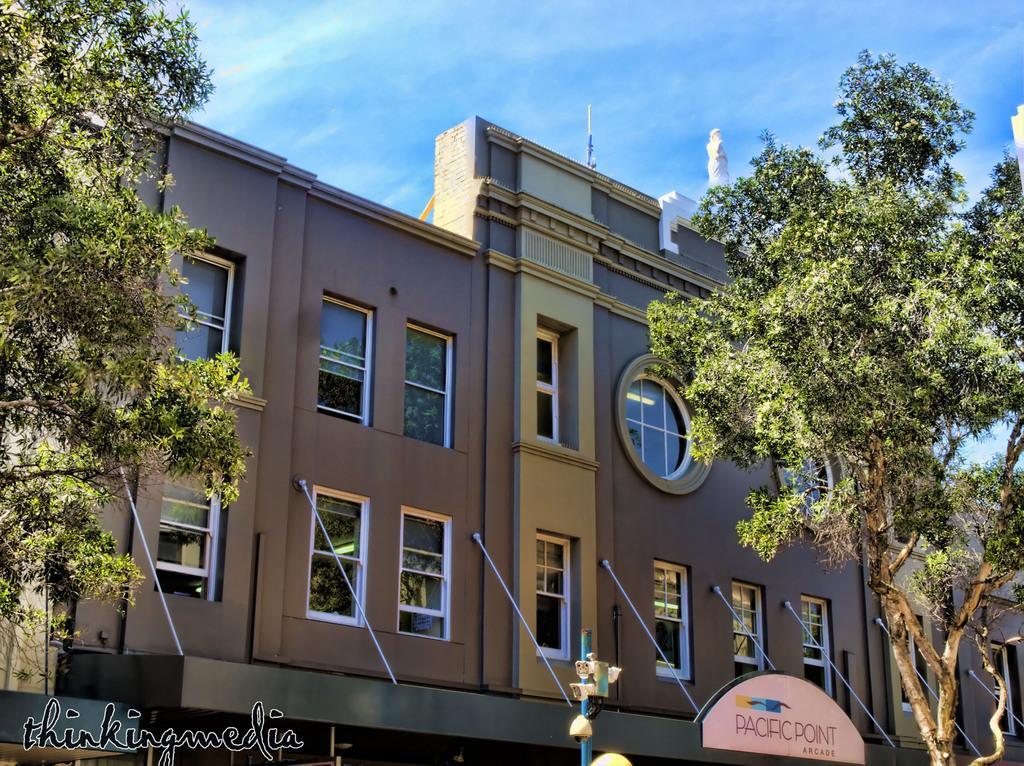Please provide a concise description of this image. In this picture we can see a building with windows and a board and on the building there is a statue. In front of the building there is a pole and trees and behind the building there is the sky. On the image there is a watermark. 